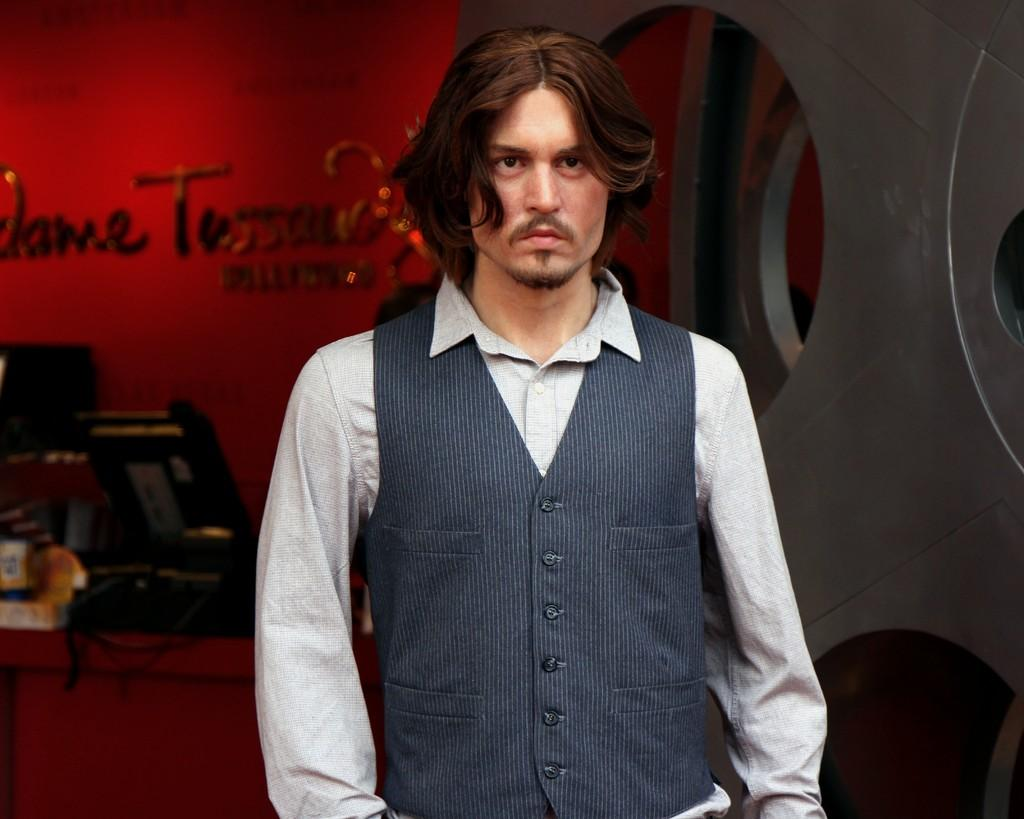What is the main subject of the image? There is a man standing in the image. What can be seen behind the man? There is a red color wall in the image. What is written or depicted on the wall? The wall has some text on it. What is in front of the wall? There are some unspecified things in front of the wall. How does the actor's knee affect the expansion of the wall in the image? There is no actor or mention of expansion in the image. The wall is a static background element, and there is no indication of any movement or change in the image. 